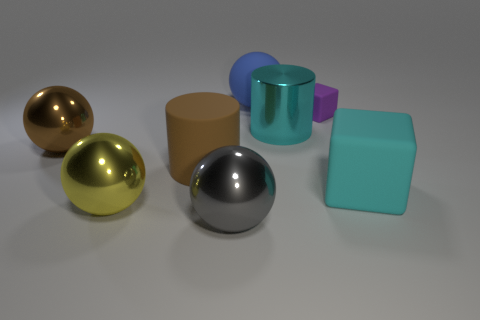Is there anything else that is the same size as the purple matte cube?
Offer a terse response. No. What material is the big blue object?
Keep it short and to the point. Rubber. What is the cylinder left of the gray metallic sphere left of the large blue thing behind the tiny matte thing made of?
Provide a short and direct response. Rubber. There is a cube that is in front of the big metal cylinder; does it have the same size as the cylinder that is on the left side of the cyan metal object?
Provide a succinct answer. Yes. How many other things are there of the same material as the small cube?
Keep it short and to the point. 3. How many matte things are large cylinders or green cylinders?
Your answer should be very brief. 1. Are there fewer yellow balls than brown objects?
Offer a very short reply. Yes. Is the size of the purple rubber block the same as the gray sphere that is to the left of the blue matte object?
Offer a terse response. No. Are there any other things that are the same shape as the blue rubber object?
Keep it short and to the point. Yes. The purple block has what size?
Your answer should be compact. Small. 